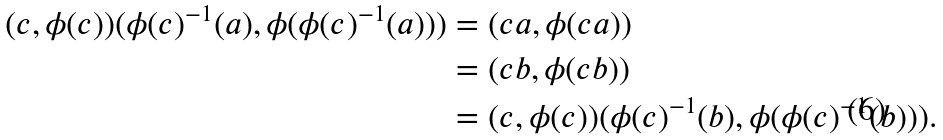<formula> <loc_0><loc_0><loc_500><loc_500>( c , \phi ( c ) ) ( \phi ( c ) ^ { - 1 } ( a ) , \phi ( \phi ( c ) ^ { - 1 } ( a ) ) ) & = ( c a , \phi ( c a ) ) \\ & = ( c b , \phi ( c b ) ) \\ & = ( c , \phi ( c ) ) ( \phi ( c ) ^ { - 1 } ( b ) , \phi ( \phi ( c ) ^ { - 1 } ( b ) ) ) .</formula> 